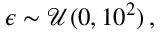Convert formula to latex. <formula><loc_0><loc_0><loc_500><loc_500>\epsilon \sim \mathcal { U } ( 0 , 1 0 ^ { 2 } ) \, ,</formula> 